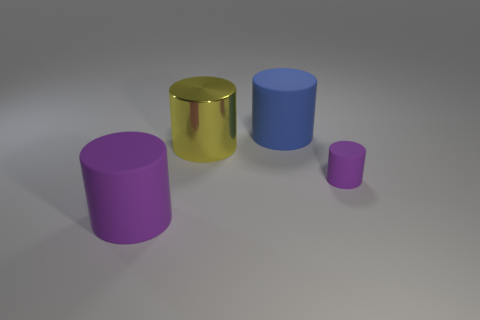Is the color of the large rubber cylinder that is left of the blue matte cylinder the same as the large rubber thing that is behind the tiny purple object?
Keep it short and to the point. No. The other object that is the same color as the tiny thing is what size?
Your response must be concise. Large. Are there any large purple matte cylinders?
Offer a terse response. Yes. The big rubber object that is in front of the purple object right of the big matte cylinder right of the yellow object is what shape?
Give a very brief answer. Cylinder. There is a large blue thing; how many matte cylinders are in front of it?
Provide a short and direct response. 2. Is the material of the big thing that is left of the metal thing the same as the yellow thing?
Your answer should be very brief. No. What number of other objects are the same shape as the blue object?
Offer a very short reply. 3. There is a purple object to the right of the large rubber cylinder that is on the left side of the large blue cylinder; what number of large blue matte objects are behind it?
Your answer should be very brief. 1. What color is the large matte cylinder that is in front of the yellow object?
Your response must be concise. Purple. Does the big matte object that is to the left of the large yellow thing have the same color as the big metal thing?
Give a very brief answer. No. 